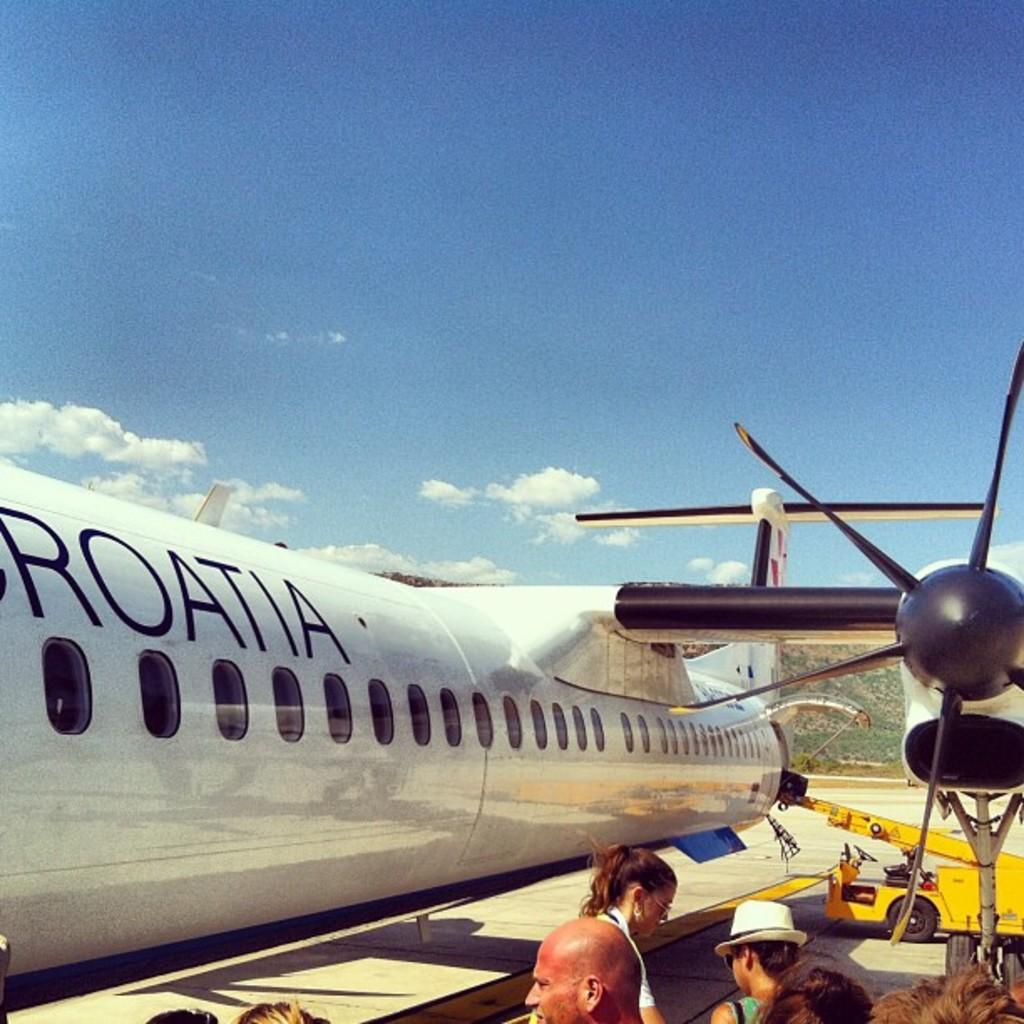<image>
Relay a brief, clear account of the picture shown. People standing outside near a white Croatia airlines plane. 